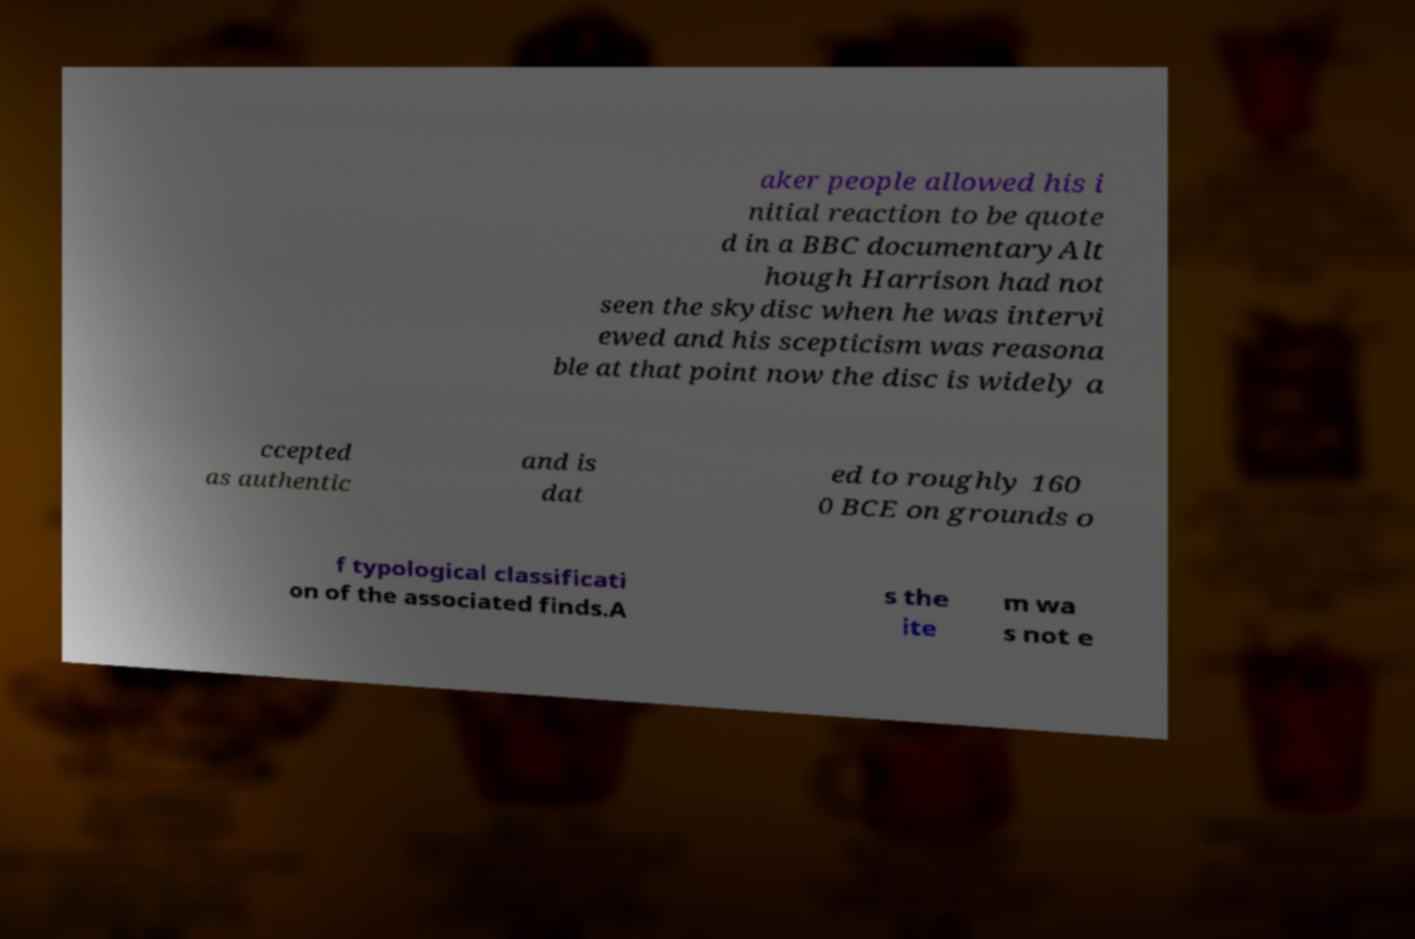Can you accurately transcribe the text from the provided image for me? aker people allowed his i nitial reaction to be quote d in a BBC documentaryAlt hough Harrison had not seen the skydisc when he was intervi ewed and his scepticism was reasona ble at that point now the disc is widely a ccepted as authentic and is dat ed to roughly 160 0 BCE on grounds o f typological classificati on of the associated finds.A s the ite m wa s not e 